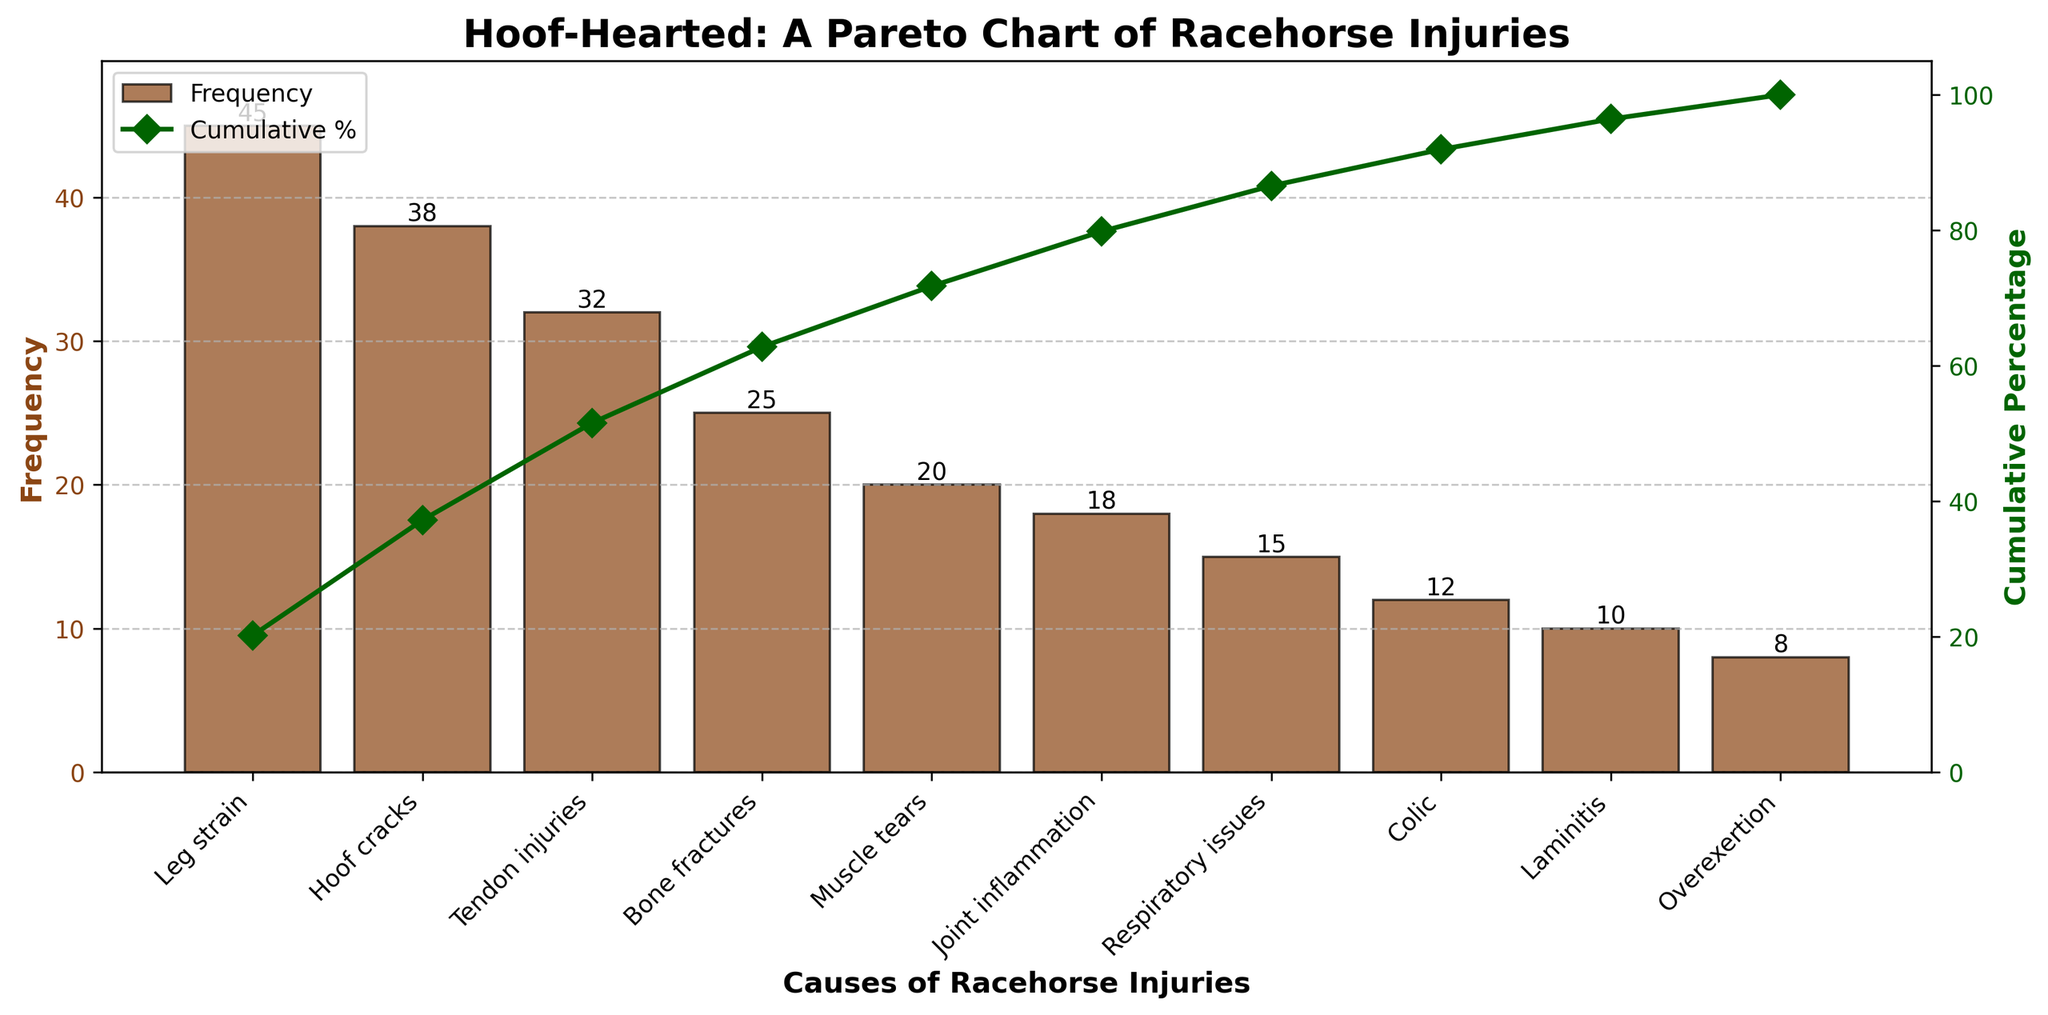What is the title of the Pareto chart? The title of the chart is typically found at the top of the figure and serves to describe the main topic or focus of the chart. In this case, the title is placed at the top of the chart to provide context about the data being visualized, which is racehorse injuries.
Answer: Hoof-Hearted: A Pareto Chart of Racehorse Injuries What is the most common cause of racehorse injuries? By examining the bars on the leftmost side of the Pareto chart, we can identify the cause associated with the highest bar, which indicates the highest frequency.
Answer: Leg strain Which cause of racehorse injuries ranks fourth by occurrence? The fourth bar from the left should be identified and its corresponding cause should be noted. Count the bars in descending order of height to find the fourth one.
Answer: Bone fractures What is the cumulative percentage for the top three causes of racehorse injuries? To calculate the cumulative percentage, we sum the frequencies of the top three causes and then look at where this sum falls on the cumulative percentage line graph. The top three causes are Leg strain (45), Hoof cracks (38), and Tendon injuries (32). Their cumulative frequency is 45+38+32 = 115.
Answer: 59.2% Which injury has a frequency just below Muscle tears? By identifying the bar corresponding to Muscle tears, which is the fifth highest bar, we look at the next bar to its immediate right for the next lower frequency.
Answer: Joint inflammation What is the percentage of racehorse injuries caused by the top 5 reasons? The percentage is derived from the cumulative percentage line graph at the top 5 causes' sum. These are Leg strain (45), Hoof cracks (38), Tendon injuries (32), Bone fractures (25), and Muscle tears (20), totaling 160 injuries. Calculate the percentage relative to the total number of injuries, the cumulative sum of the top five divisions translated to percentage.
Answer: 82.5% Which injury cause has the exact middle rank in terms of frequency, and what is its frequency? There are 10 types of injuries listed. The middle injury can be found at the fifth position when causes are ordered by frequency. Start counting from the most frequent and move down to the middle.
Answer: Muscle tears, 20 Which injuries contribute to the cumulative percentage reaching over 90%? By tracing the cumulative percentage line close to the 90% y-axis value and looking downward vertically to the x-axis at the closest points that cross it, then count how many causes occur before reaching this point.
Answer: The first 8 injuries Out of Overexertion and Laminitis, which has a higher frequency and by how much? Look at the heights of the bars corresponding to Overexertion and Laminitis. Compare their heights numerically, subtracting the smaller from the larger.
Answer: Laminitis has a higher frequency by 2 